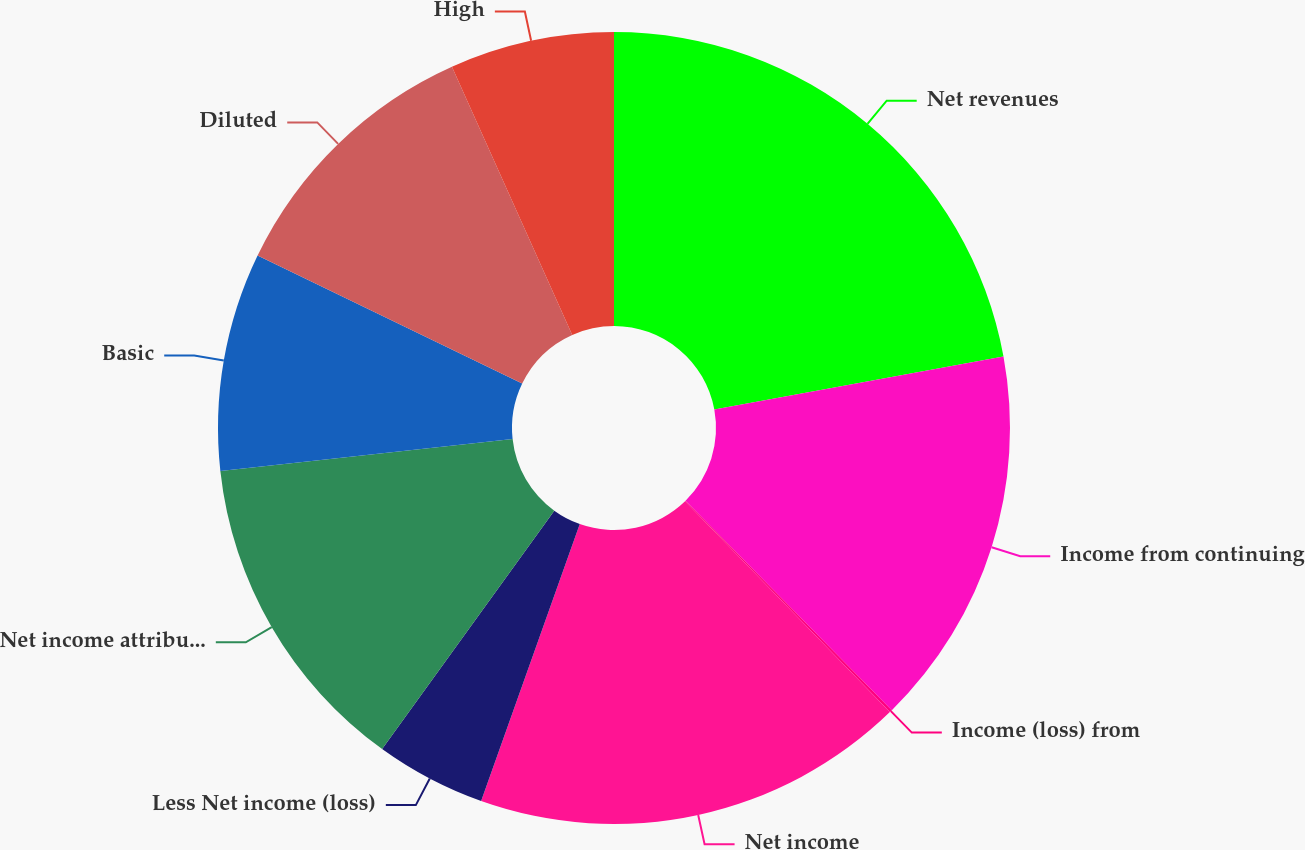Convert chart. <chart><loc_0><loc_0><loc_500><loc_500><pie_chart><fcel>Net revenues<fcel>Income from continuing<fcel>Income (loss) from<fcel>Net income<fcel>Less Net income (loss)<fcel>Net income attributable to<fcel>Basic<fcel>Diluted<fcel>High<nl><fcel>22.11%<fcel>15.51%<fcel>0.11%<fcel>17.71%<fcel>4.51%<fcel>13.31%<fcel>8.91%<fcel>11.11%<fcel>6.71%<nl></chart> 